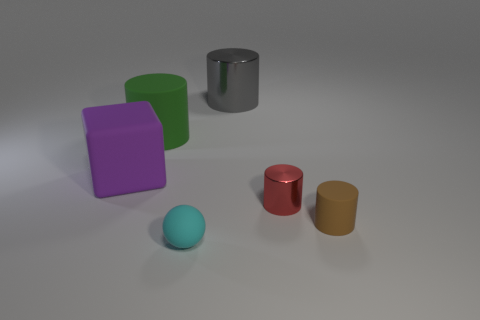Subtract all red cylinders. How many cylinders are left? 3 Add 3 purple matte cubes. How many objects exist? 9 Subtract all brown cylinders. How many cylinders are left? 3 Subtract 1 cubes. How many cubes are left? 0 Add 3 large red metallic cubes. How many large red metallic cubes exist? 3 Subtract 1 purple blocks. How many objects are left? 5 Subtract all blocks. How many objects are left? 5 Subtract all brown blocks. Subtract all red spheres. How many blocks are left? 1 Subtract all red balls. How many brown cylinders are left? 1 Subtract all small brown rubber cylinders. Subtract all big metal objects. How many objects are left? 4 